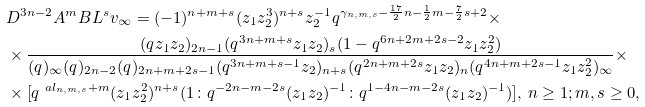Convert formula to latex. <formula><loc_0><loc_0><loc_500><loc_500>& D ^ { 3 n - 2 } A ^ { m } B L ^ { s } v _ { \infty } = ( - 1 ) ^ { n + m + s } ( z _ { 1 } z _ { 2 } ^ { 3 } ) ^ { n + s } z _ { 2 } ^ { - 1 } q ^ { \gamma _ { n , m , s } - \frac { 1 7 } { 2 } n - \frac { 1 } { 2 } m - \frac { 7 } { 2 } s + 2 } \times \\ & \times \frac { ( q z _ { 1 } z _ { 2 } ) _ { 2 n - 1 } ( q ^ { 3 n + m + s } z _ { 1 } z _ { 2 } ) _ { s } ( 1 - q ^ { 6 n + 2 m + 2 s - 2 } z _ { 1 } z _ { 2 } ^ { 2 } ) } { ( q ) _ { \infty } ( q ) _ { 2 n - 2 } ( q ) _ { 2 n + m + 2 s - 1 } ( q ^ { 3 n + m + s - 1 } z _ { 2 } ) _ { n + s } ( q ^ { 2 n + m + 2 s } z _ { 1 } z _ { 2 } ) _ { n } ( q ^ { 4 n + m + 2 s - 1 } z _ { 1 } z _ { 2 } ^ { 2 } ) _ { \infty } } \times \\ & \times [ q ^ { \ a l _ { n , m , s } + m } ( z _ { 1 } z _ { 2 } ^ { 2 } ) ^ { n + s } ( 1 \colon q ^ { - 2 n - m - 2 s } ( z _ { 1 } z _ { 2 } ) ^ { - 1 } \colon q ^ { 1 - 4 n - m - 2 s } ( z _ { 1 } z _ { 2 } ) ^ { - 1 } ) ] , \, n \geq 1 ; m , s \geq 0 ,</formula> 